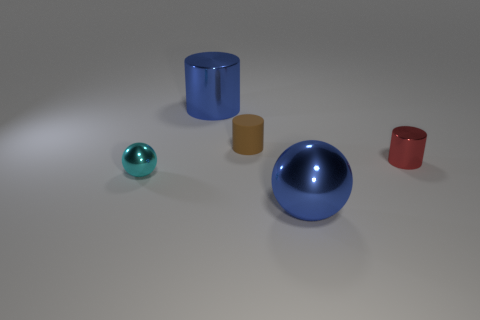Subtract all brown matte cylinders. How many cylinders are left? 2 Add 4 small blue metallic cubes. How many objects exist? 9 Subtract 3 cylinders. How many cylinders are left? 0 Subtract all blue cylinders. How many purple spheres are left? 0 Subtract all small blue shiny spheres. Subtract all tiny red objects. How many objects are left? 4 Add 1 large blue metallic objects. How many large blue metallic objects are left? 3 Add 5 small yellow rubber cylinders. How many small yellow rubber cylinders exist? 5 Subtract all cyan balls. How many balls are left? 1 Subtract 1 blue balls. How many objects are left? 4 Subtract all spheres. How many objects are left? 3 